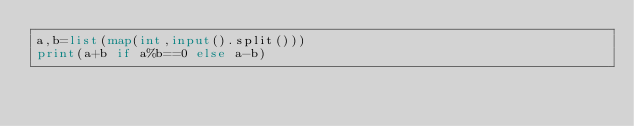<code> <loc_0><loc_0><loc_500><loc_500><_Python_>a,b=list(map(int,input().split()))
print(a+b if a%b==0 else a-b)</code> 